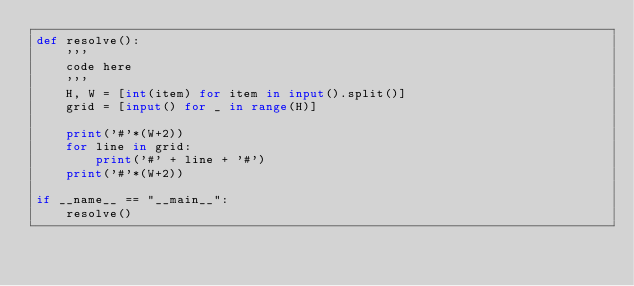<code> <loc_0><loc_0><loc_500><loc_500><_Python_>def resolve():
    '''
    code here
    '''
    H, W = [int(item) for item in input().split()]
    grid = [input() for _ in range(H)]
    
    print('#'*(W+2))
    for line in grid:
        print('#' + line + '#')
    print('#'*(W+2))

if __name__ == "__main__":
    resolve()
</code> 